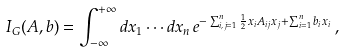<formula> <loc_0><loc_0><loc_500><loc_500>I _ { G } ( A , b ) = \int _ { - \infty } ^ { + \infty } d x _ { 1 } \cdots d x _ { n } \, e ^ { - \sum _ { i , j = 1 } ^ { n } \frac { 1 } { 2 } x _ { i } A _ { i j } x _ { j } + \sum _ { i = 1 } ^ { n } b _ { i } x _ { i } } \, ,</formula> 